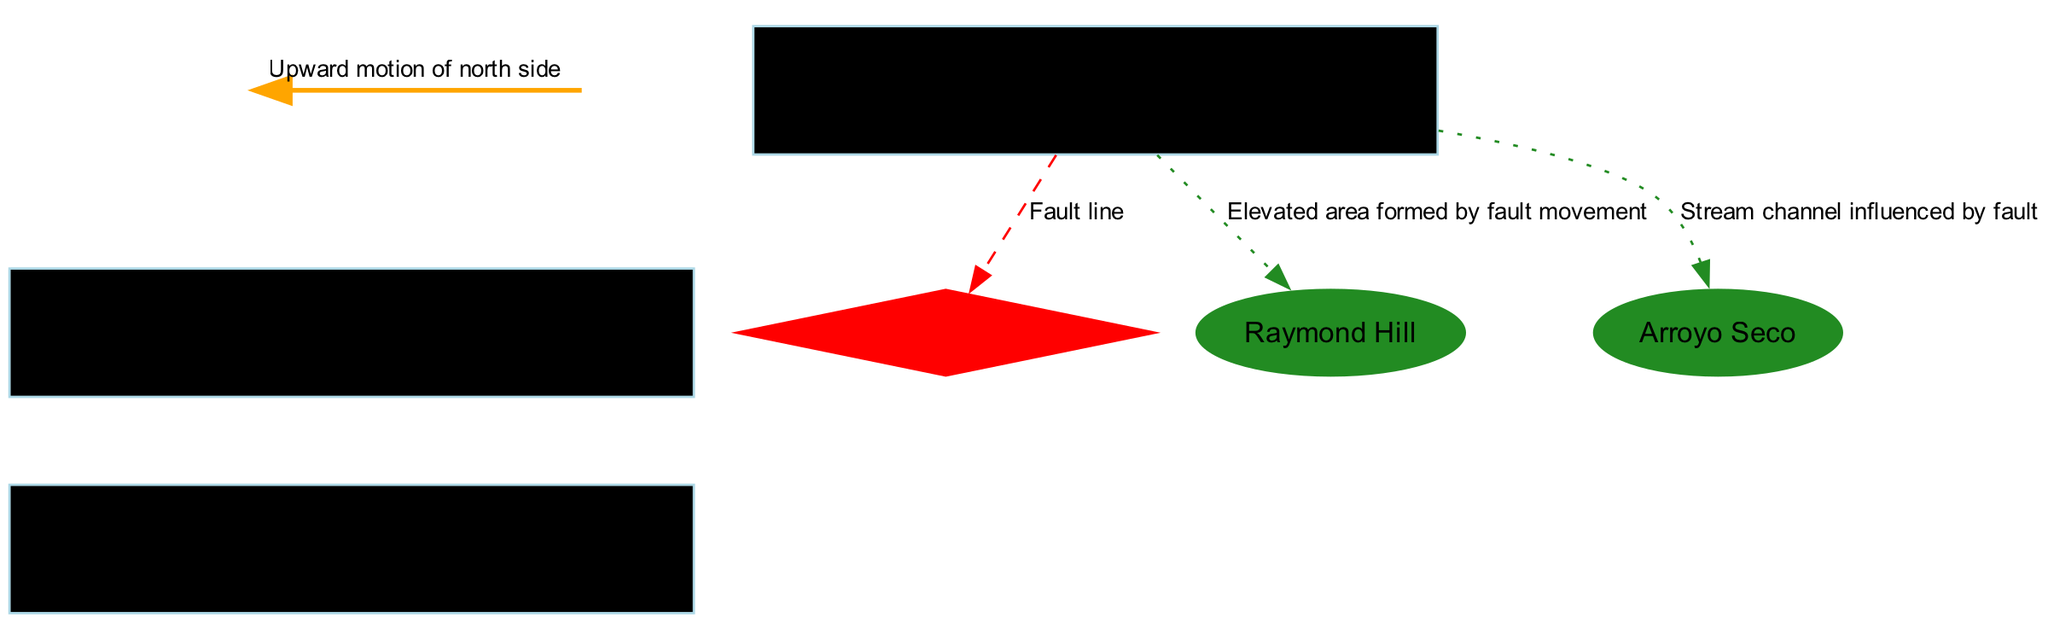What is the top layer in the diagram? The diagram lists the "Surface" as the first element, which represents Pasadena's urban landscape. I identified it based on position, as it is the first layer in the vertical arrangement.
Answer: Surface What type of fault is the Raymond Fault? The description provided for the Raymond Fault indicates it is an "Active reverse fault." This classification is noted directly from the feature's definition in the diagram.
Answer: Active reverse fault How many layers are present in the diagram? The diagram outlines four distinct layers. These layers are: Surface, Alluvium, and Bedrock, totaling three layers mentioned in the visual structure.
Answer: Three What is the function of the orange arrow in the diagram? The orange arrow's description states its function is to show "Upward motion of north side." Thus, by analyzing where the arrow is placed, it's clear it illustrates movement associated with the fault mechanics.
Answer: Upward motion of north side Which feature is formed by fault movement? The feature known as "Raymond Hill" is specifically described as being formed by fault movement. This connection is made by referencing both the description and placement of the feature near the fault in the diagram.
Answer: Raymond Hill What type of material is represented by the Alluvium layer? The description of the Alluvium layer states it consists of "Sedimentary deposits from San Gabriel Mountains." This classification can be confirmed by reading the definition accompanying the layer in the diagram.
Answer: Sedimentary deposits from San Gabriel Mountains How is Arroyo Seco influenced by the Raymond Fault? The Arroyo Seco is described as a "Stream channel influenced by fault." This indicates that the fault's geological activities have a direct effect on the stream's formation and path, which is noted in the relationship conveyed within the diagram.
Answer: Stream channel influenced by fault What color is used to represent the Raymond Fault? The Raymond Fault is represented in red color in the diagram, as indicated by the node's specific color attribute. Therefore, by identifying the color coding used for the fault feature.
Answer: Red 